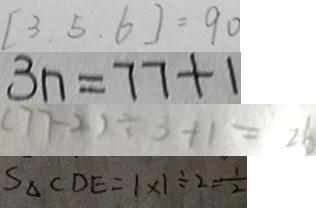Convert formula to latex. <formula><loc_0><loc_0><loc_500><loc_500>[ 3 . 5 . 6 ] = 9 0 
 3 n = 7 7 + 1 
 ( 7 7 - 2 ) \div 3 + 1 = 2 6 
 S _ { \Delta } C D E = 1 \times 1 \div 2 = \frac { 1 } { 2 }</formula> 